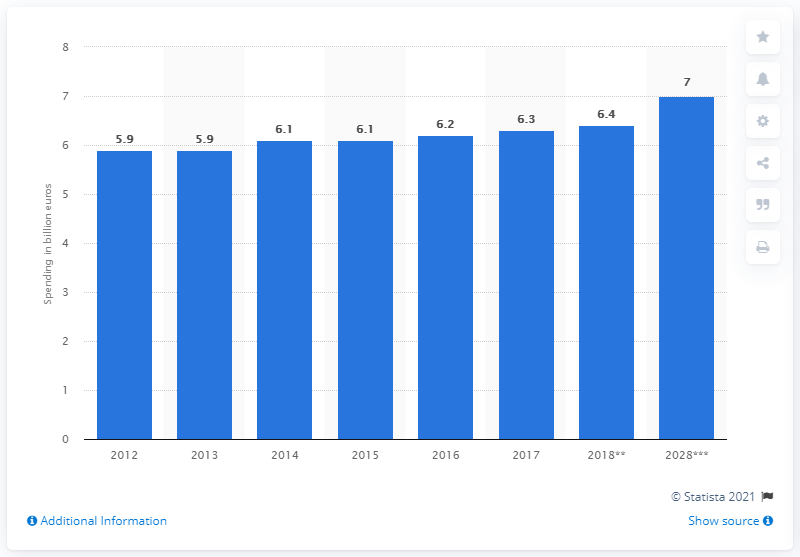Indicate a few pertinent items in this graphic. In 2017, Portugal's domestic travel expenditure was 6.3. 